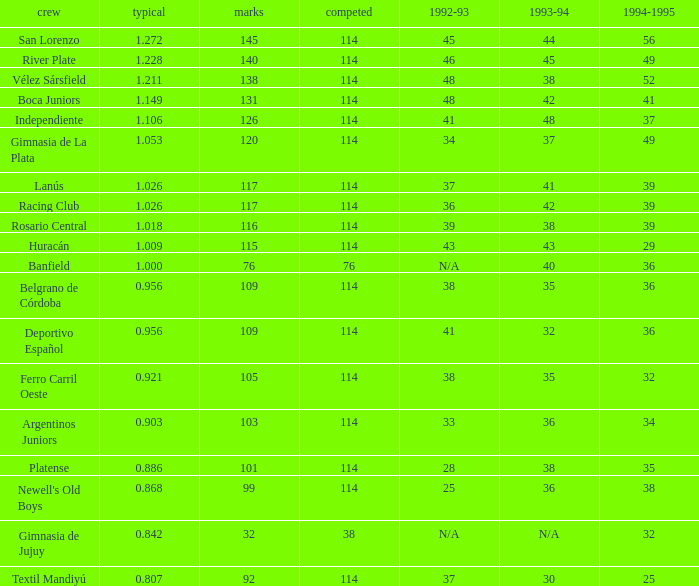Name the most played 114.0. 